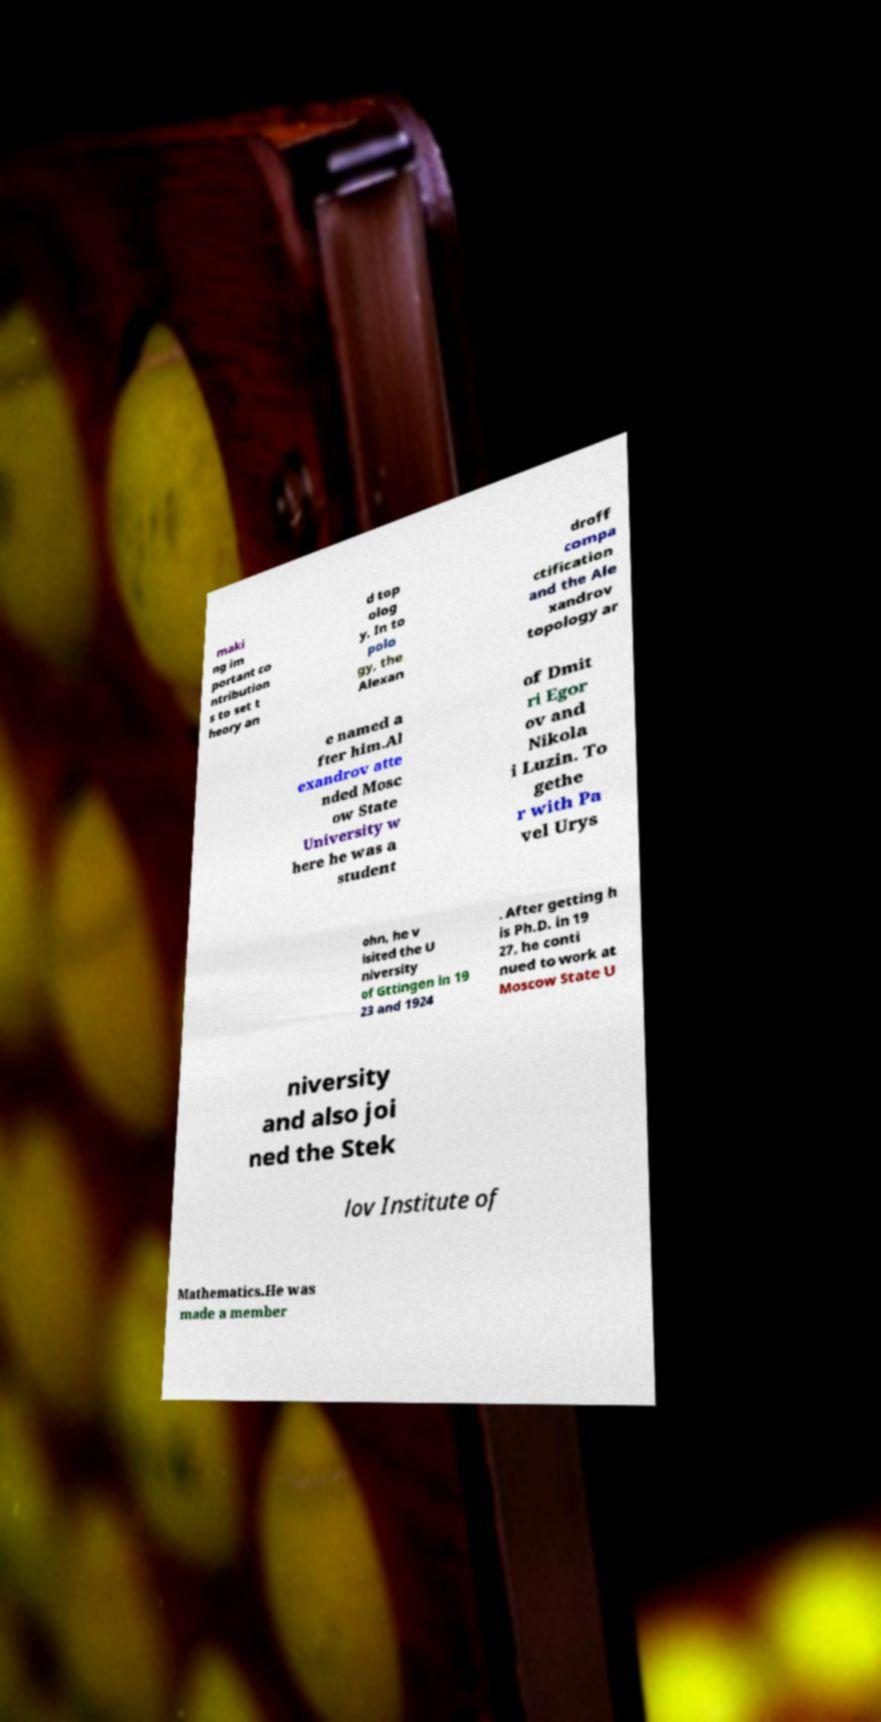I need the written content from this picture converted into text. Can you do that? maki ng im portant co ntribution s to set t heory an d top olog y. In to polo gy, the Alexan droff compa ctification and the Ale xandrov topology ar e named a fter him.Al exandrov atte nded Mosc ow State University w here he was a student of Dmit ri Egor ov and Nikola i Luzin. To gethe r with Pa vel Urys ohn, he v isited the U niversity of Gttingen in 19 23 and 1924 . After getting h is Ph.D. in 19 27, he conti nued to work at Moscow State U niversity and also joi ned the Stek lov Institute of Mathematics.He was made a member 